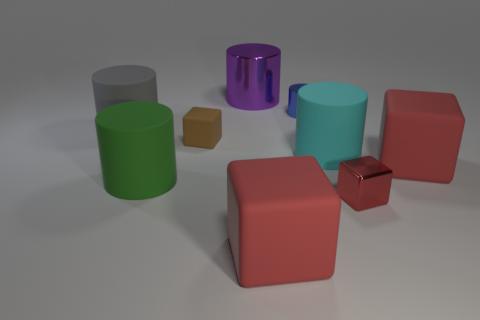Subtract all red cylinders. How many red blocks are left? 3 Subtract 2 cylinders. How many cylinders are left? 3 Subtract all red cylinders. Subtract all green cubes. How many cylinders are left? 5 Subtract all blocks. How many objects are left? 5 Add 2 tiny metal things. How many tiny metal things exist? 4 Subtract 1 brown blocks. How many objects are left? 8 Subtract all brown matte objects. Subtract all brown rubber things. How many objects are left? 7 Add 8 cyan things. How many cyan things are left? 9 